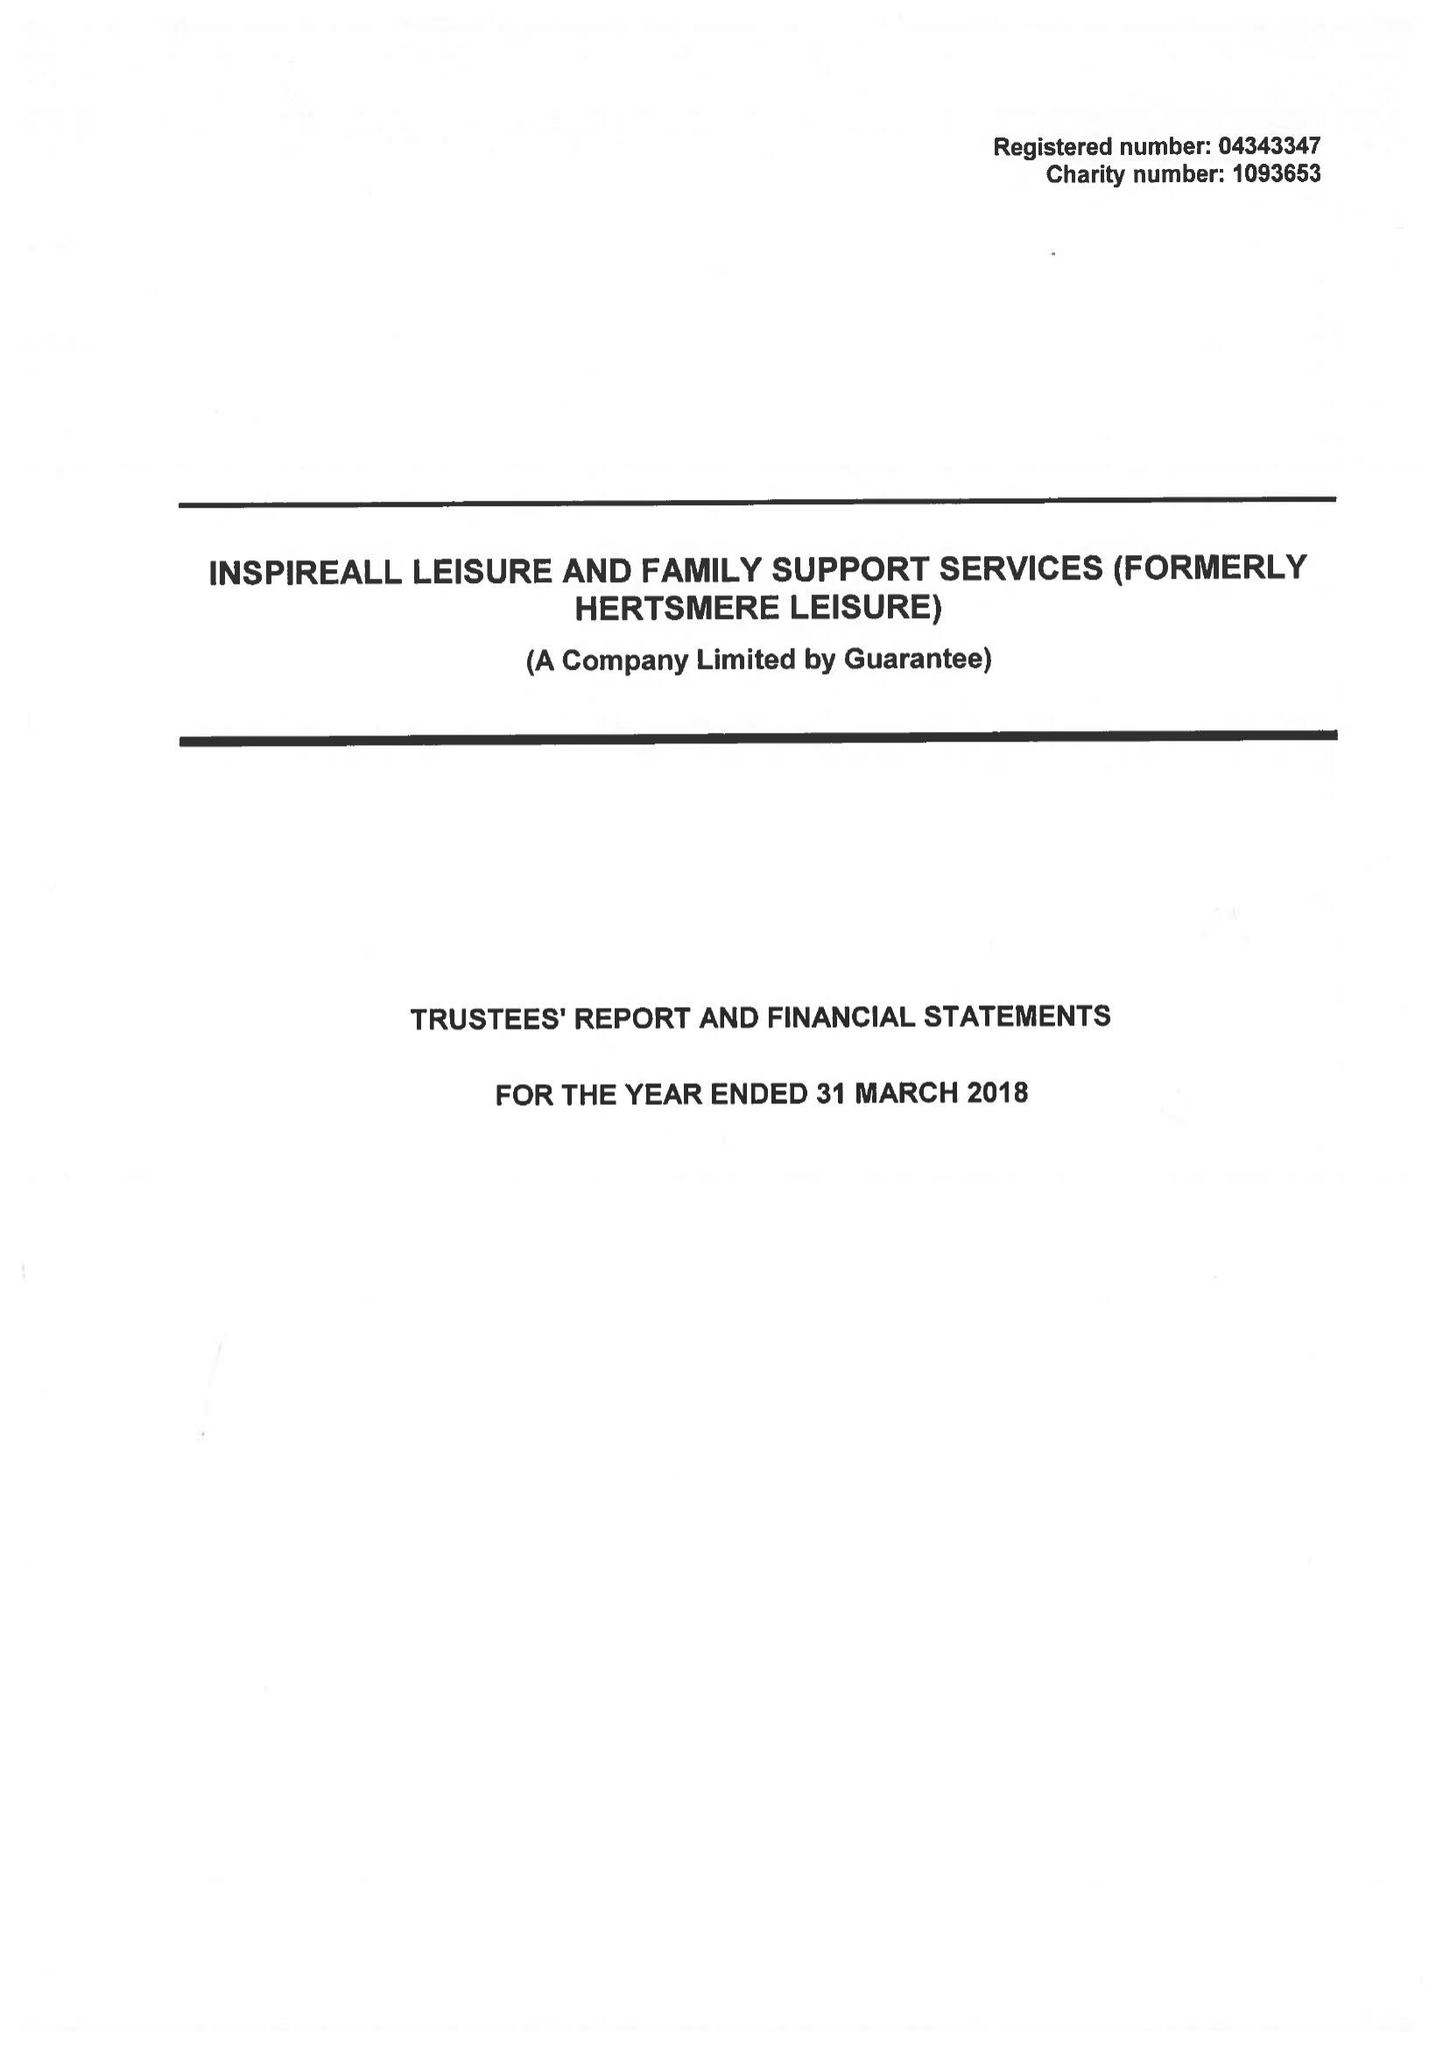What is the value for the address__post_town?
Answer the question using a single word or phrase. BOREHAMWOOD 